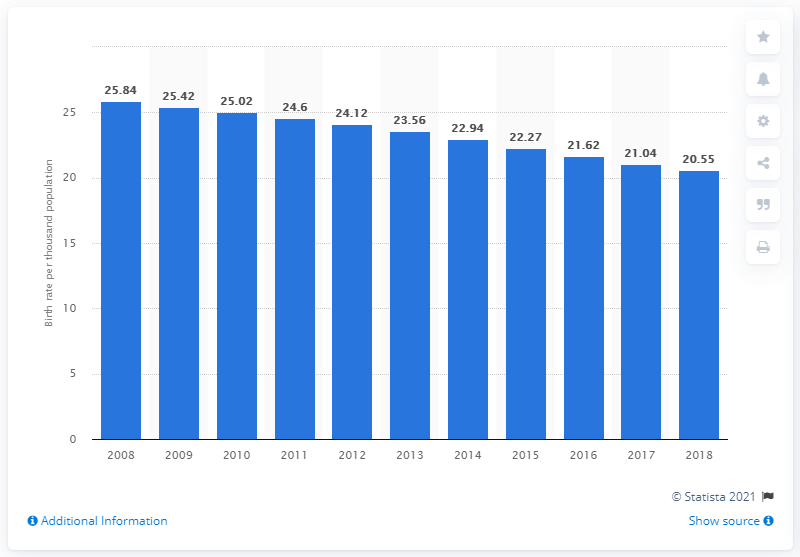Draw attention to some important aspects in this diagram. In 2018, the crude birth rate in the Philippines was 20.55. 